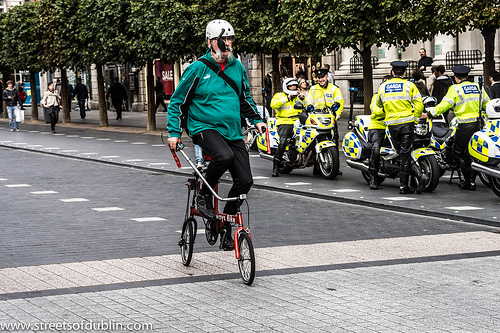<image>
Is the tree behind the man? Yes. From this viewpoint, the tree is positioned behind the man, with the man partially or fully occluding the tree. Is the bike in the man? No. The bike is not contained within the man. These objects have a different spatial relationship. 